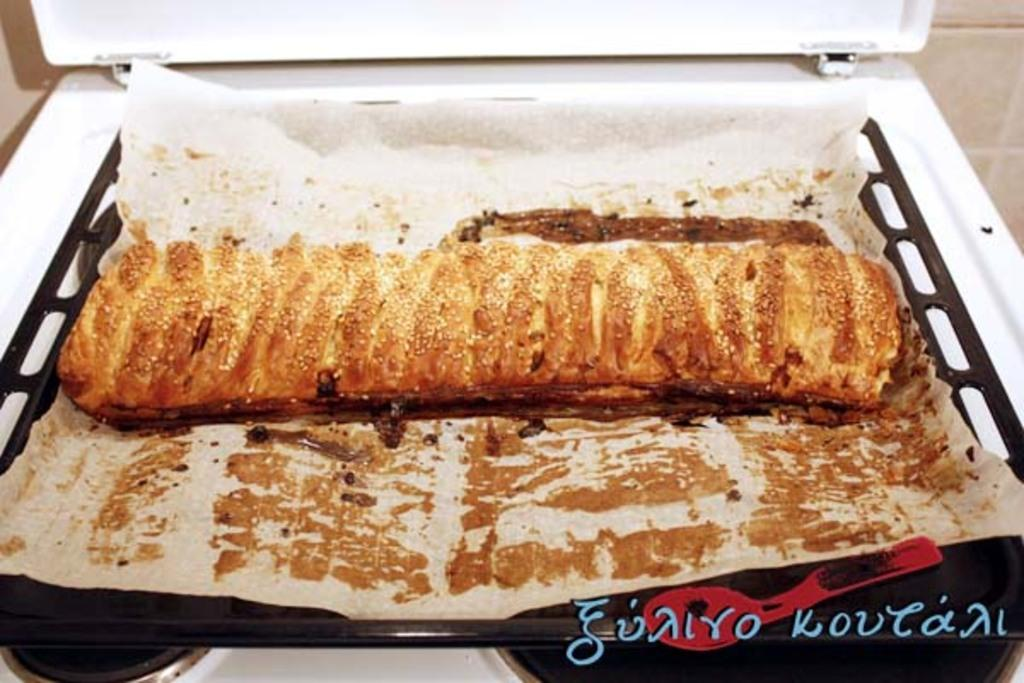What is the main object in the image? There is a dish in the image. What type of flooring is visible in the image? There are white color tiles in the image. What nation is represented by the dish in the image? A: The image does not provide any information about the nation represented by the dish. 